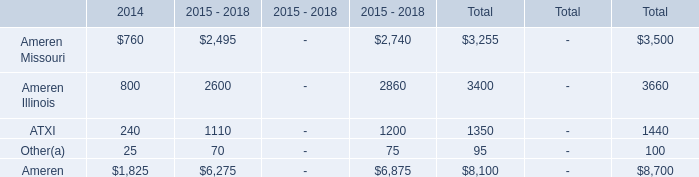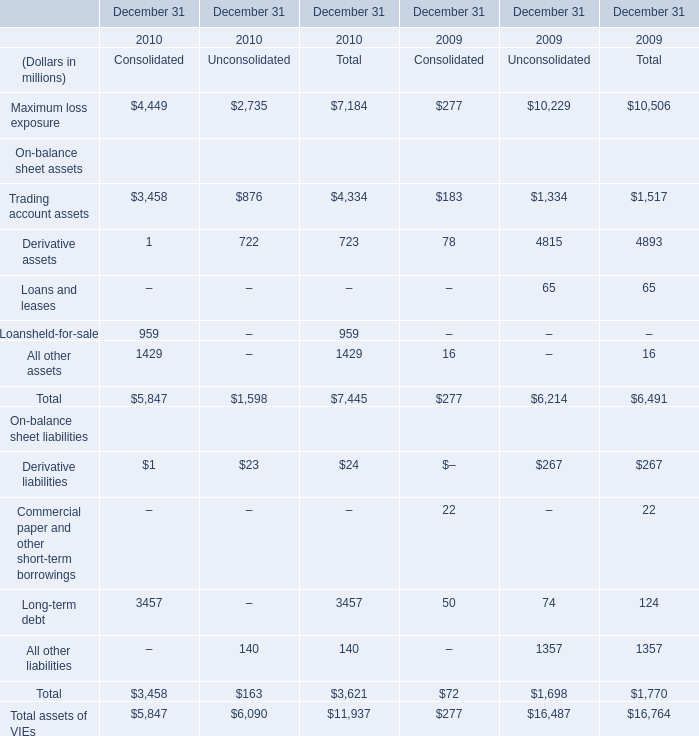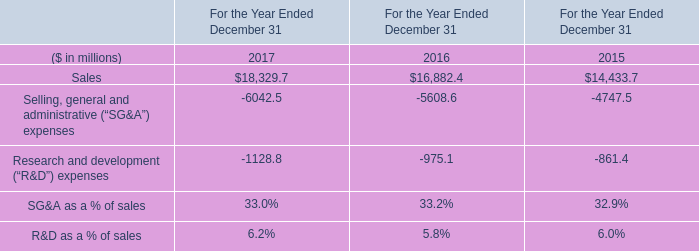What's the current increasing rate of the total long-term debt? 
Computations: ((3457 - 124) / 124)
Answer: 26.87903. 